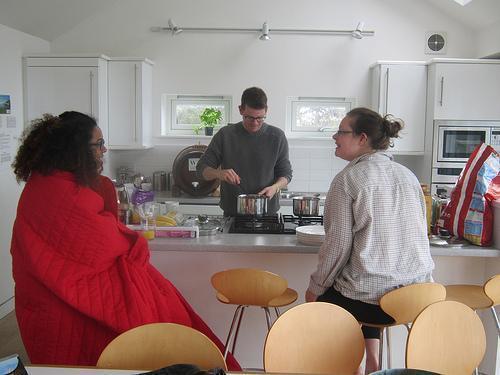How many people are pictured?
Give a very brief answer. 3. How many windows are in the picture?
Give a very brief answer. 2. 